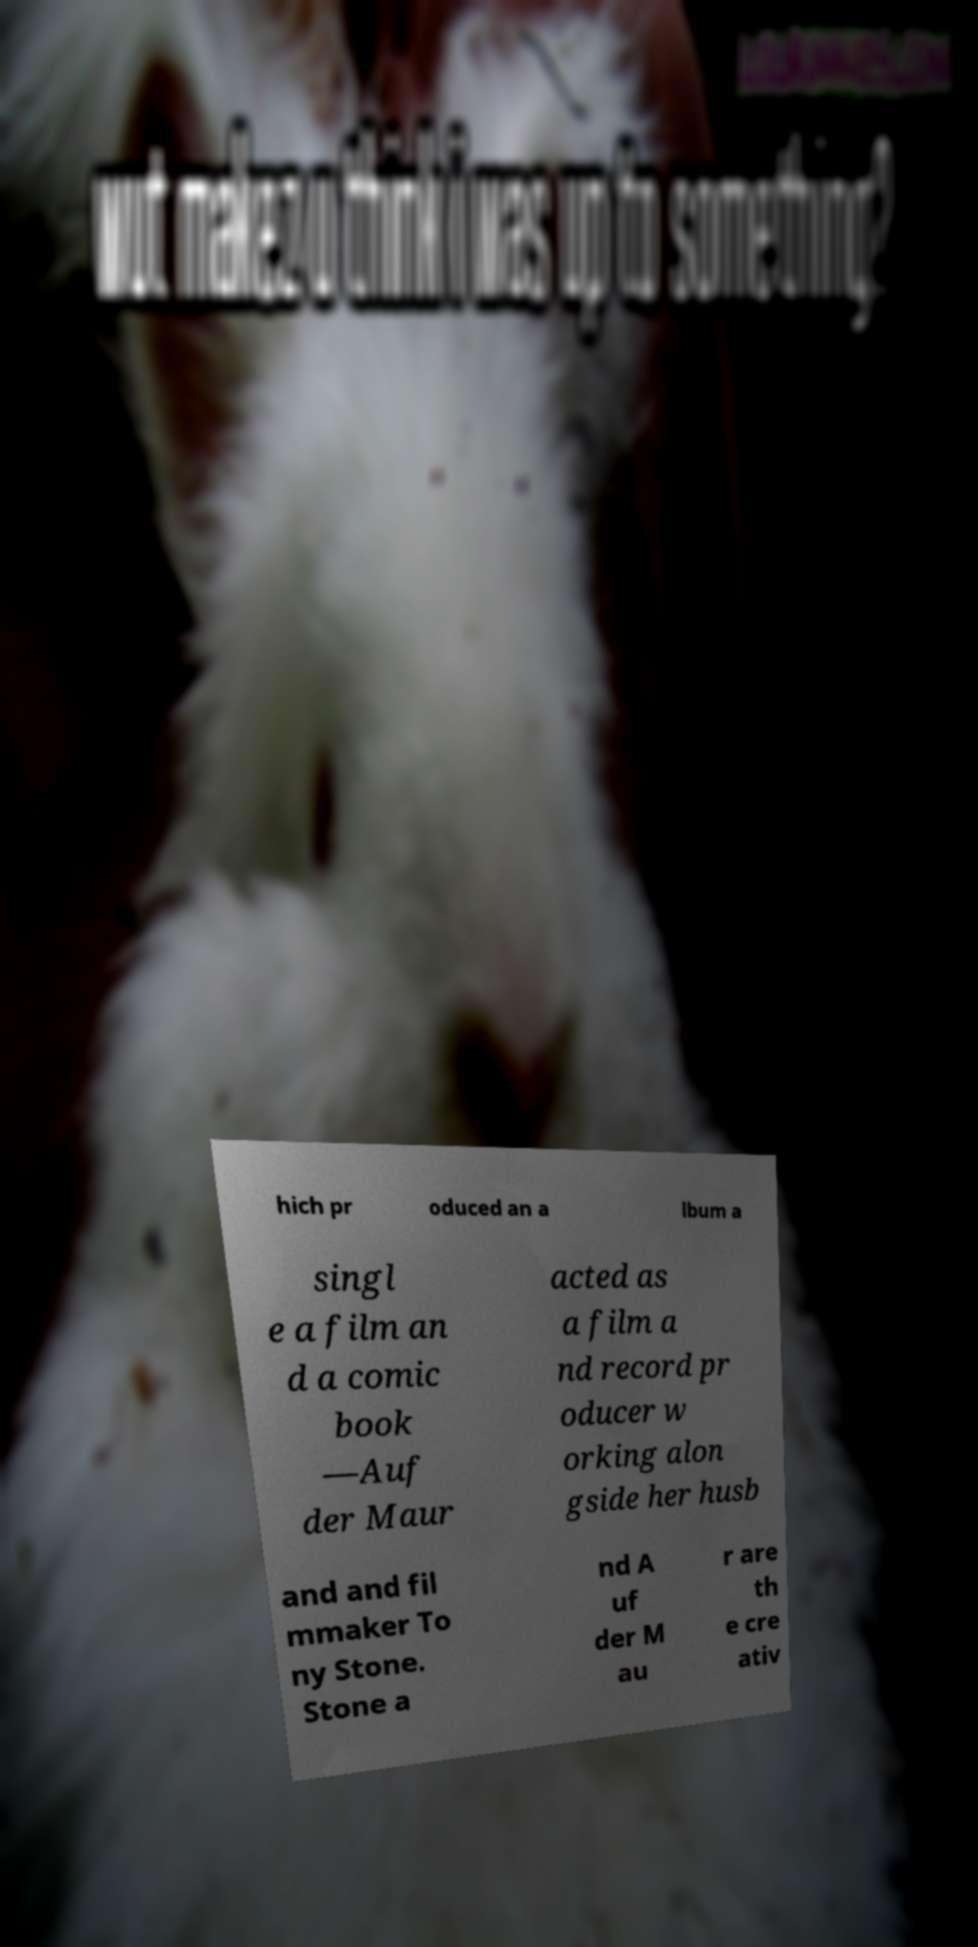Please read and relay the text visible in this image. What does it say? hich pr oduced an a lbum a singl e a film an d a comic book —Auf der Maur acted as a film a nd record pr oducer w orking alon gside her husb and and fil mmaker To ny Stone. Stone a nd A uf der M au r are th e cre ativ 